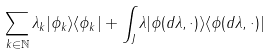<formula> <loc_0><loc_0><loc_500><loc_500>\sum _ { k \in \mathbb { N } } \lambda _ { k } | \phi _ { k } \rangle \langle \phi _ { k } | + \int _ { J } { \lambda | \phi ( d \lambda , \cdot ) \rangle \langle \phi ( d \lambda , \cdot ) | }</formula> 